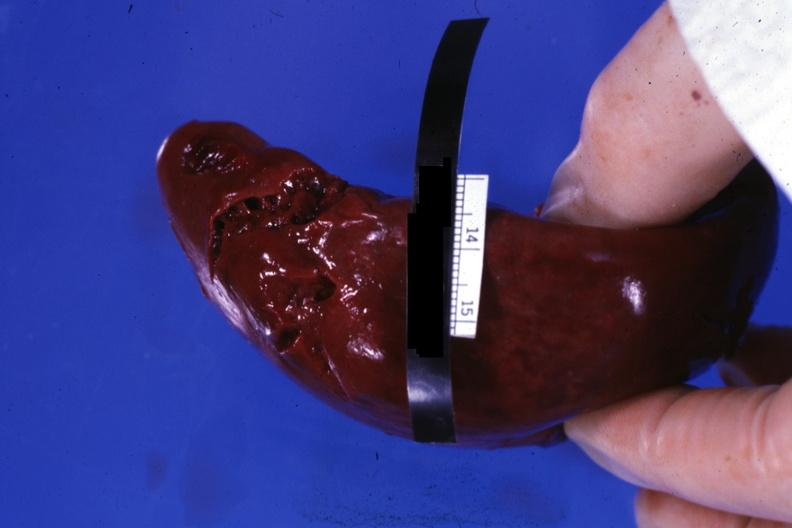where is this part in?
Answer the question using a single word or phrase. Spleen 